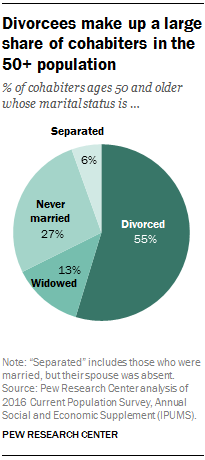Indicate a few pertinent items in this graphic. The pie chart shows that 27% of the respondents have never been married. The difference in value between "Widowed" and "Separated" is 7. 